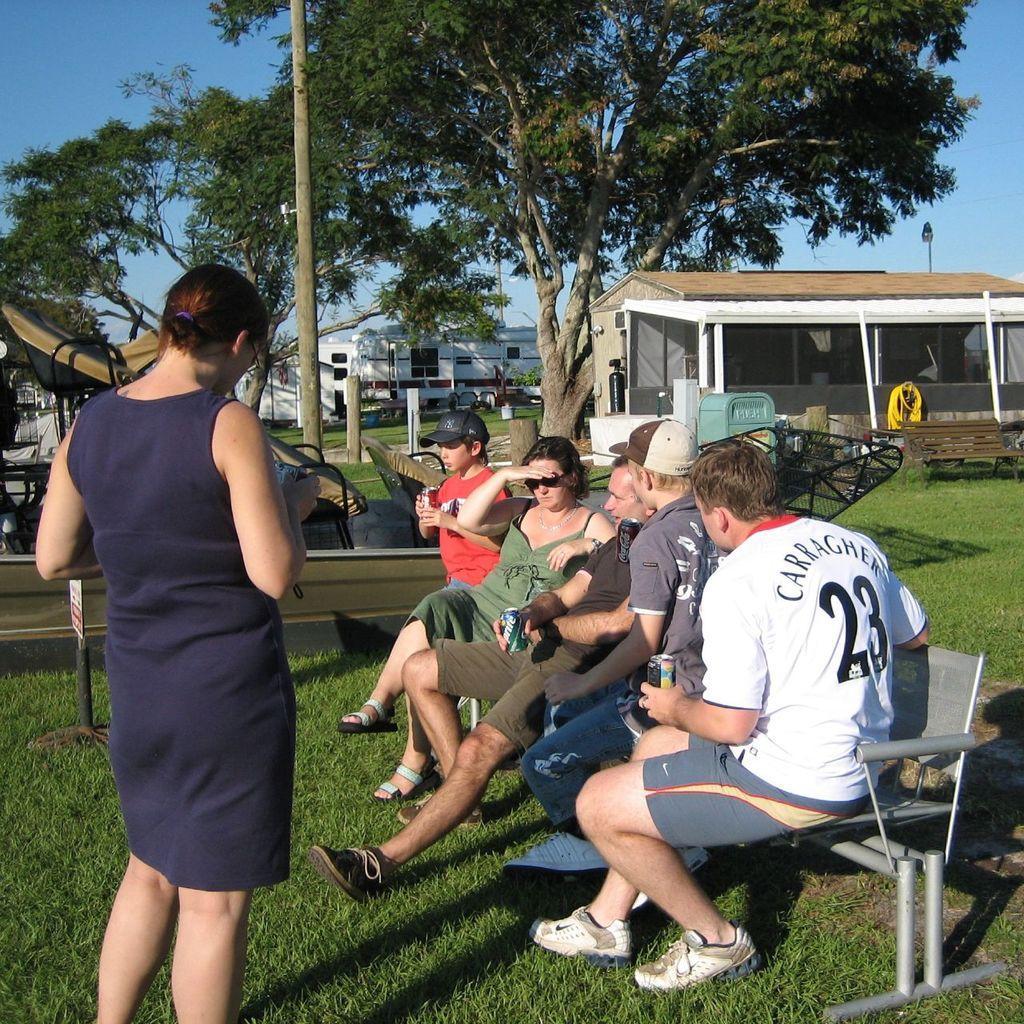Describe this image in one or two sentences. On the left side, there is a woman in a violet color dress, standing. On the right side, there are other persons sitting on a bench, which is arranged on the grass on the ground. In the background, there are other furniture, poles, buildings, trees and there are clouds in the blue sky. 